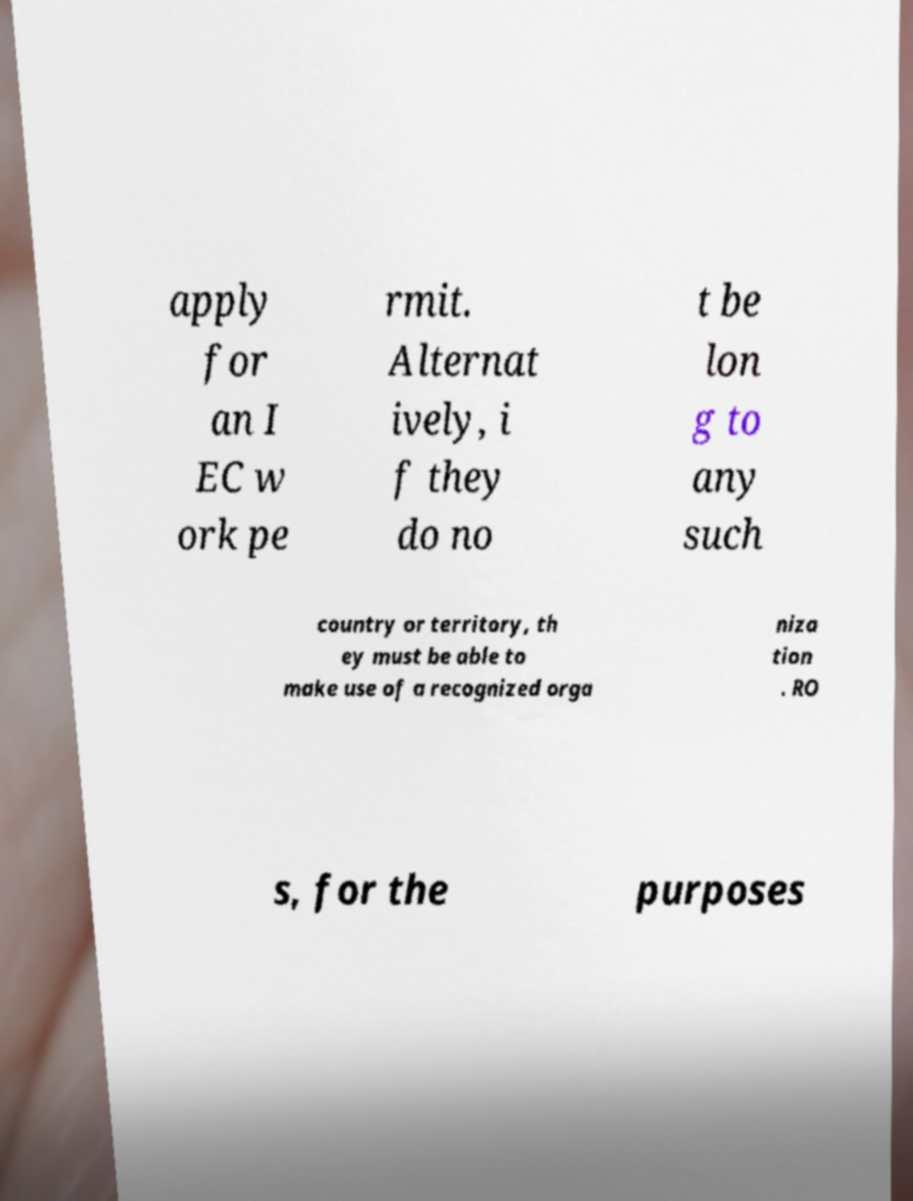For documentation purposes, I need the text within this image transcribed. Could you provide that? apply for an I EC w ork pe rmit. Alternat ively, i f they do no t be lon g to any such country or territory, th ey must be able to make use of a recognized orga niza tion . RO s, for the purposes 